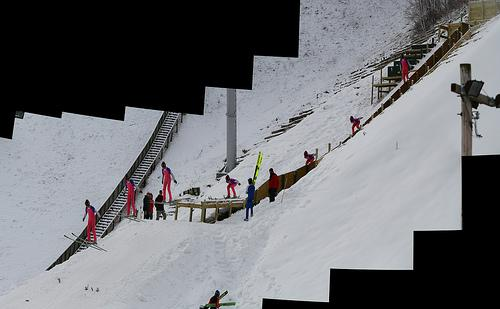Provide a brief description of the primary action taking place in this image. Skiers are preparing to ski down a snow covered mountain, carrying their skis, walking up the hill, and jumping off a lift. Describe the area and people's outfits in the image. The area is a snow-covered mountain, and the people in the image are wearing red and black ski outfits, as well as an all-blue outfit, with a variety of skis. List the sports activity and different equipment and clothing visible in the image. Activity: Skiing. Equipment: yellow, green skis, wooden pole with black object; Clothing: red and black ski outfit, all-blue outfit. Mention the colors and types of outfits that the people in the image are wearing. People in the image wear red and black ski outfits, as well as an all-blue outfit, while carrying yellow and green skis. State the main action happening in the image and any distinctive elements associated with the people. Skiers are getting ready to ski down the mountain and are carrying their skis, wearing colorful ski outfits, and participating in various skiing activities. Explain the setting of this image and what the people in the image are doing. The people are on a snow-covered mountain, holding skis, wearing colorful ski suits, and participating in skiing activities like walking up the hill and jumping off lifts. What activity are people engaging in and what are some distinct elements found in the image? People are skiing on a snow-covered mountain and the image features skiers holding skis, jumping off lifts, and wearing different colored ski outfits. Using vivid language, briefly describe the central focus and actions in this image. A flurry of snow-kissed skiers garbed in vibrant outfits ascend the pristine, powder-blanketed mountain, toting their gear and leaping from lifts in eager anticipation. Summarize the primary subject and setting of the image. The primary subject is skiers on a snow-covered mountain getting ready to ski, carrying their skis, and wearing various colorful ski outfits. Describe any notable features within this snowy scene. The scene includes tracks leading to the mountain's top, a pole with a green banner, stairs to the top of the hill, and a wooden pole with a black object. 